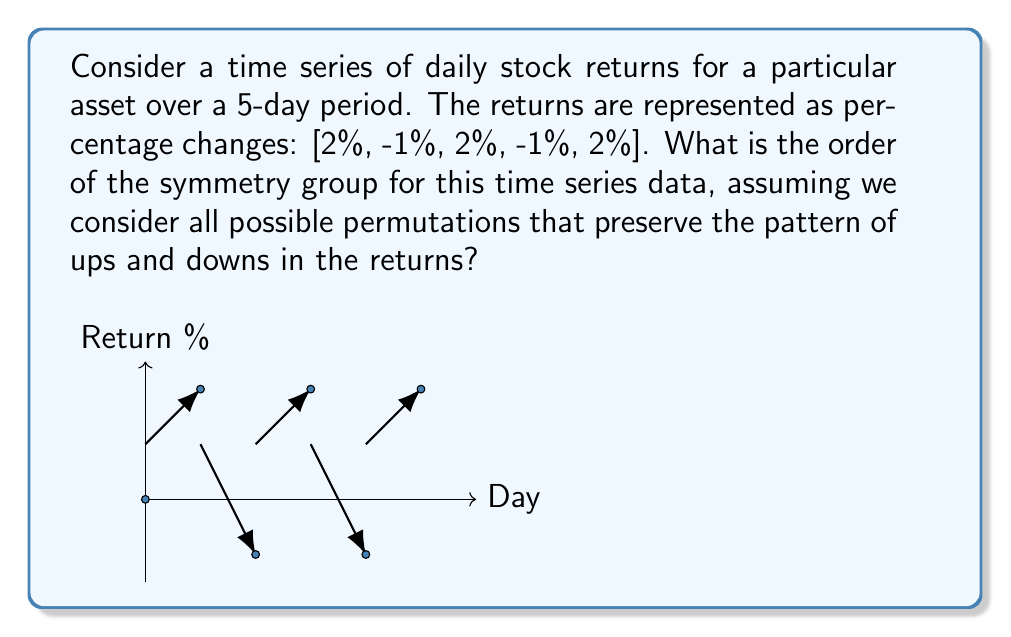Help me with this question. To solve this problem, we need to follow these steps:

1) First, observe the pattern in the time series: [2%, -1%, 2%, -1%, 2%]

2) The pattern of ups and downs is: [Up, Down, Up, Down, Up]

3) To preserve this pattern, we can only consider permutations that keep the "Up" days together and the "Down" days together.

4) There are three "Up" days (2%) and two "Down" days (-1%).

5) The symmetry group will consist of permutations that:
   a) Swap the positions of the three "Up" days amongst themselves
   b) Swap the positions of the two "Down" days

6) For the three "Up" days, we have 3! = 6 possible permutations.

7) For the two "Down" days, we have 2! = 2 possible permutations.

8) By the multiplication principle, the total number of permutations that preserve the pattern is:

   $$ 6 \times 2 = 12 $$

9) The order of a group is the number of elements in the group. In this case, it's the number of permutations that preserve the pattern.

Therefore, the order of the symmetry group for this time series data is 12.
Answer: 12 